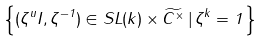<formula> <loc_0><loc_0><loc_500><loc_500>\left \{ ( \zeta ^ { u } I , \zeta ^ { - 1 } ) \in S L ( k ) \times \widetilde { { C } ^ { \times } } \, | \, \zeta ^ { k } = 1 \, \right \}</formula> 